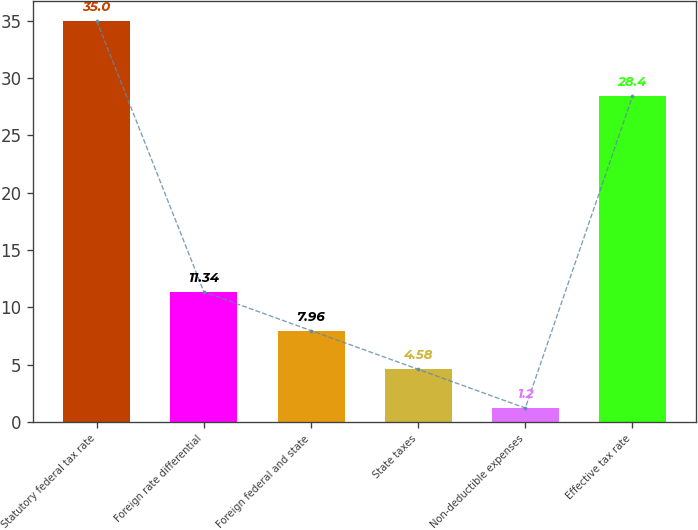Convert chart. <chart><loc_0><loc_0><loc_500><loc_500><bar_chart><fcel>Statutory federal tax rate<fcel>Foreign rate differential<fcel>Foreign federal and state<fcel>State taxes<fcel>Non-deductible expenses<fcel>Effective tax rate<nl><fcel>35<fcel>11.34<fcel>7.96<fcel>4.58<fcel>1.2<fcel>28.4<nl></chart> 